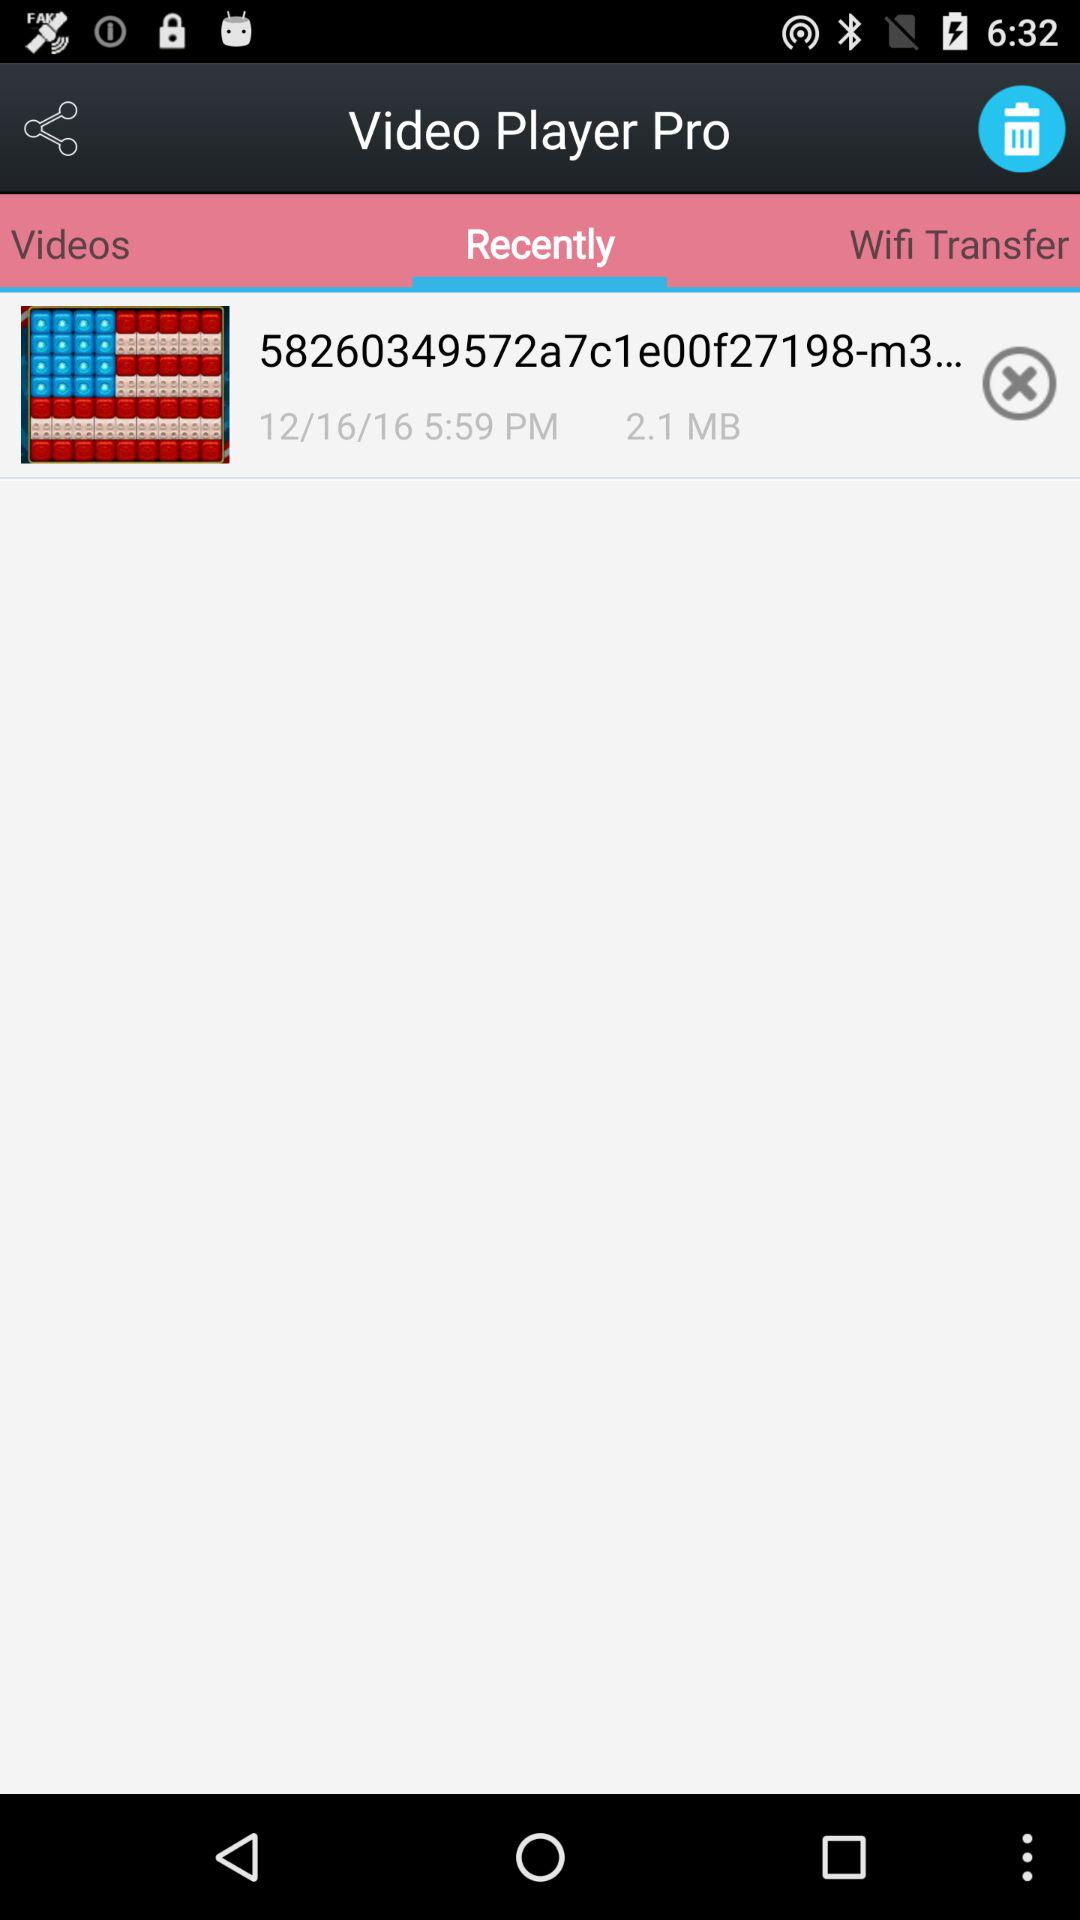What is the date and time of the file?
Answer the question using a single word or phrase. 12/16/16 5:59 PM 